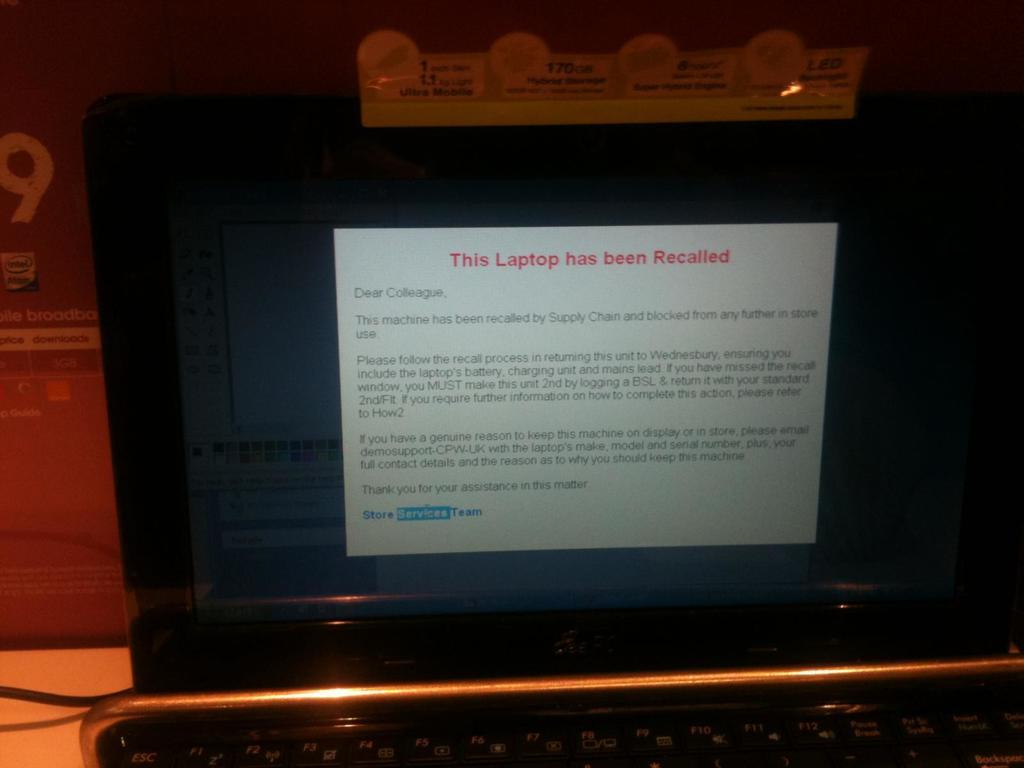<image>
Describe the image concisely. A laptop sitting on a counter displaying a message on the monitor that the laptop has been recalled. 